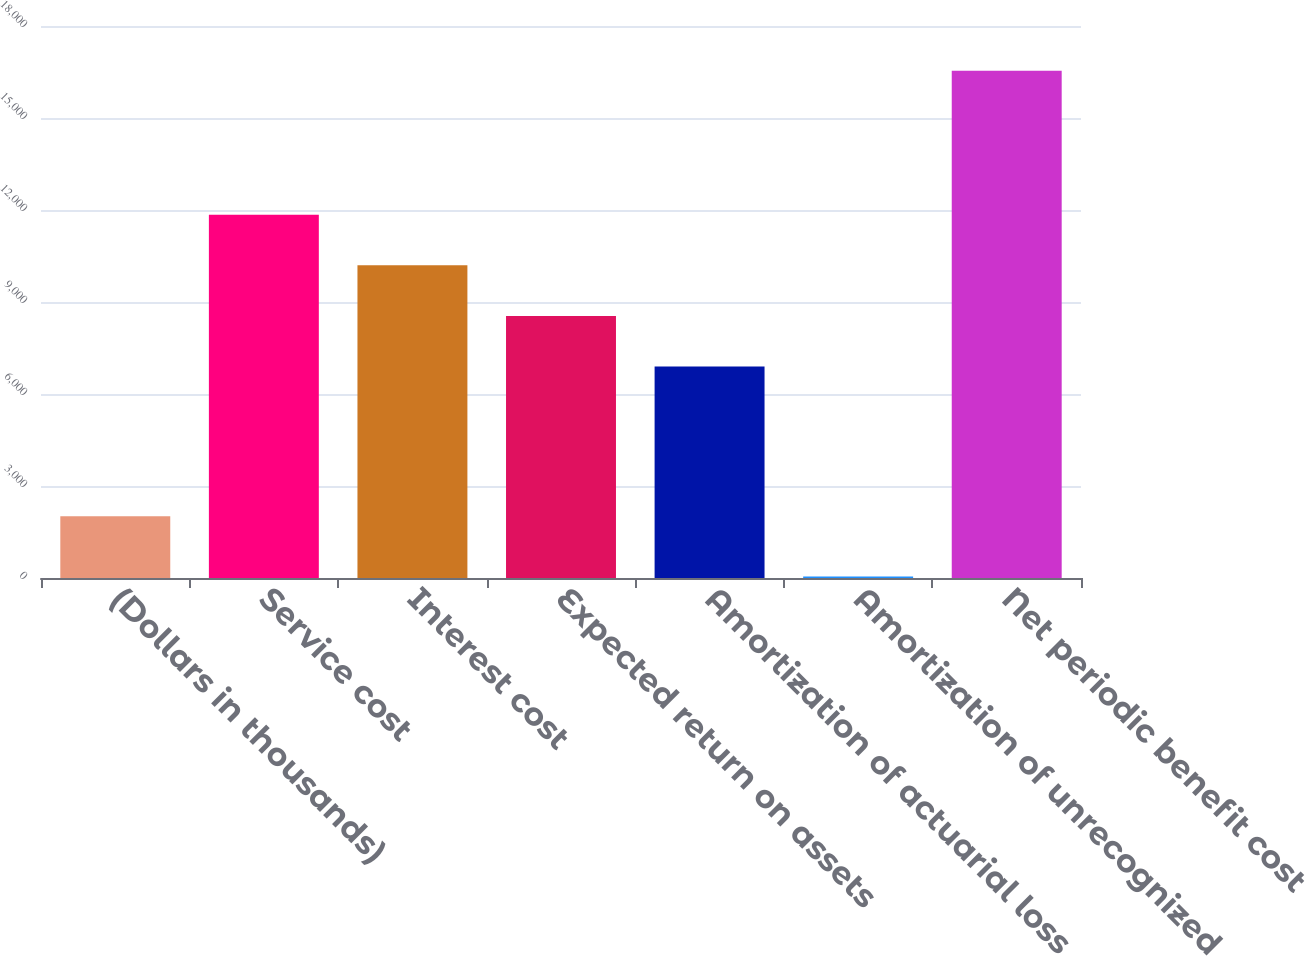<chart> <loc_0><loc_0><loc_500><loc_500><bar_chart><fcel>(Dollars in thousands)<fcel>Service cost<fcel>Interest cost<fcel>Expected return on assets<fcel>Amortization of actuarial loss<fcel>Amortization of unrecognized<fcel>Net periodic benefit cost<nl><fcel>2012<fcel>11843.9<fcel>10194.6<fcel>8545.3<fcel>6896<fcel>49<fcel>16542<nl></chart> 